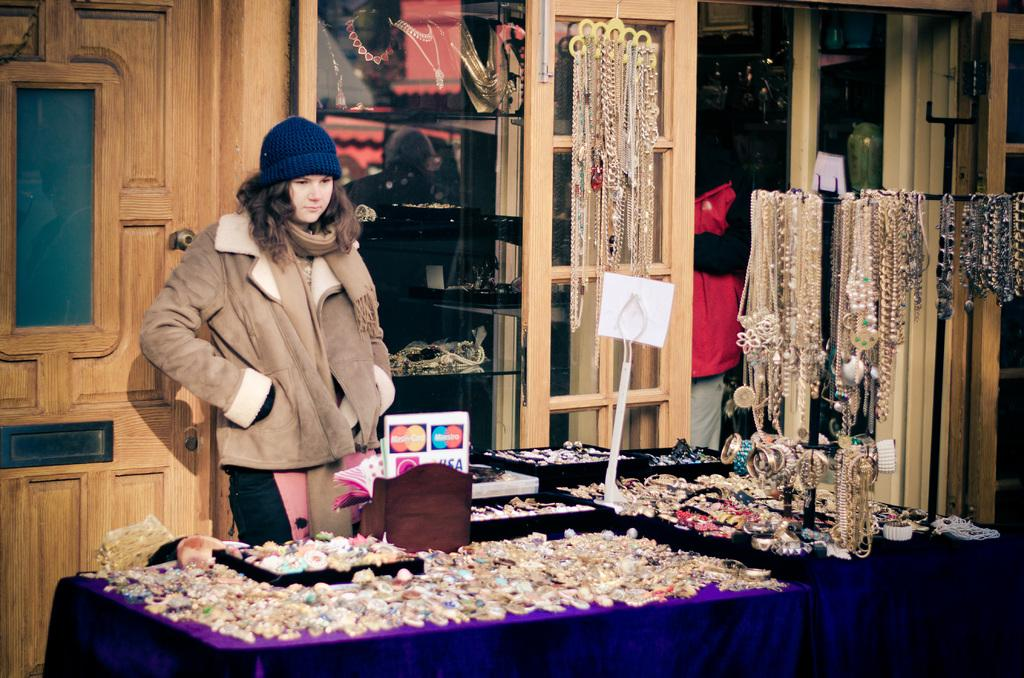Who is present in the image? There is a woman in the image. What is the woman standing in front of? The woman is standing in front of jewelry items. Can you describe the jewelry items in the image? Yes, there are jewelry items in the image, including a stand with jewels hanging on it in the right corner. What type of card is the woman holding in the image? There is no card present in the image. Is the woman taking a bath in the image? No, the woman is not taking a bath in the image; she is standing in front of jewelry items. What type of pipe is visible in the image? There is no pipe present in the image. 